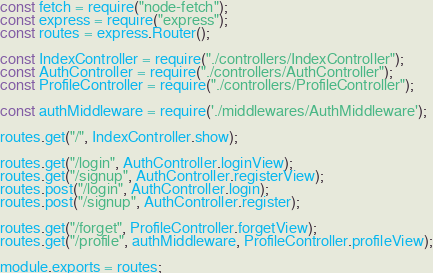Convert code to text. <code><loc_0><loc_0><loc_500><loc_500><_JavaScript_>const fetch = require("node-fetch");
const express = require("express");
const routes = express.Router();

const IndexController = require("./controllers/IndexController");
const AuthController = require("./controllers/AuthController");
const ProfileController = require("./controllers/ProfileController");

const authMiddleware = require('./middlewares/AuthMiddleware');

routes.get("/", IndexController.show);

routes.get("/login", AuthController.loginView);
routes.get("/signup", AuthController.registerView);
routes.post("/login", AuthController.login);
routes.post("/signup", AuthController.register);

routes.get("/forget", ProfileController.forgetView);
routes.get("/profile", authMiddleware, ProfileController.profileView);

module.exports = routes;
</code> 